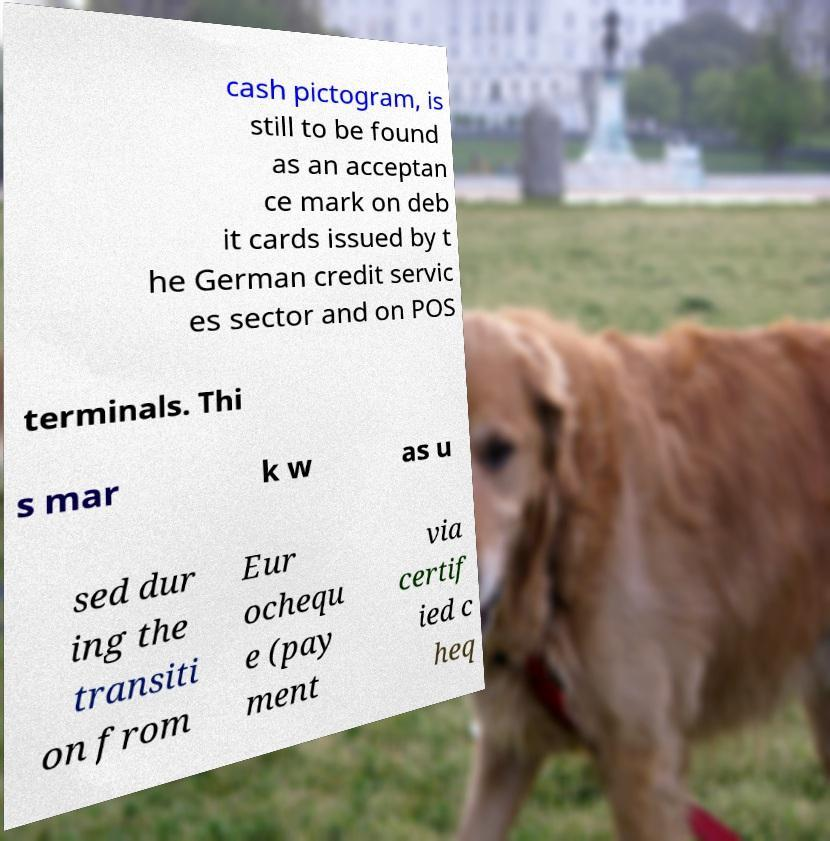Can you read and provide the text displayed in the image?This photo seems to have some interesting text. Can you extract and type it out for me? cash pictogram, is still to be found as an acceptan ce mark on deb it cards issued by t he German credit servic es sector and on POS terminals. Thi s mar k w as u sed dur ing the transiti on from Eur ochequ e (pay ment via certif ied c heq 